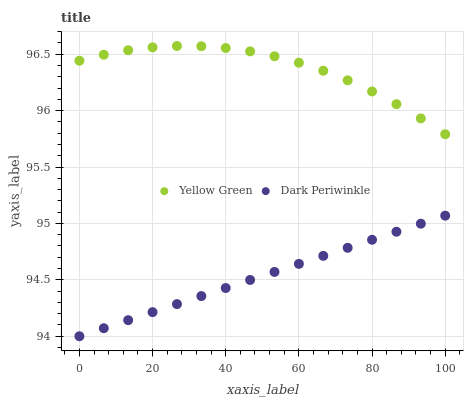Does Dark Periwinkle have the minimum area under the curve?
Answer yes or no. Yes. Does Yellow Green have the maximum area under the curve?
Answer yes or no. Yes. Does Dark Periwinkle have the maximum area under the curve?
Answer yes or no. No. Is Dark Periwinkle the smoothest?
Answer yes or no. Yes. Is Yellow Green the roughest?
Answer yes or no. Yes. Is Dark Periwinkle the roughest?
Answer yes or no. No. Does Dark Periwinkle have the lowest value?
Answer yes or no. Yes. Does Yellow Green have the highest value?
Answer yes or no. Yes. Does Dark Periwinkle have the highest value?
Answer yes or no. No. Is Dark Periwinkle less than Yellow Green?
Answer yes or no. Yes. Is Yellow Green greater than Dark Periwinkle?
Answer yes or no. Yes. Does Dark Periwinkle intersect Yellow Green?
Answer yes or no. No. 